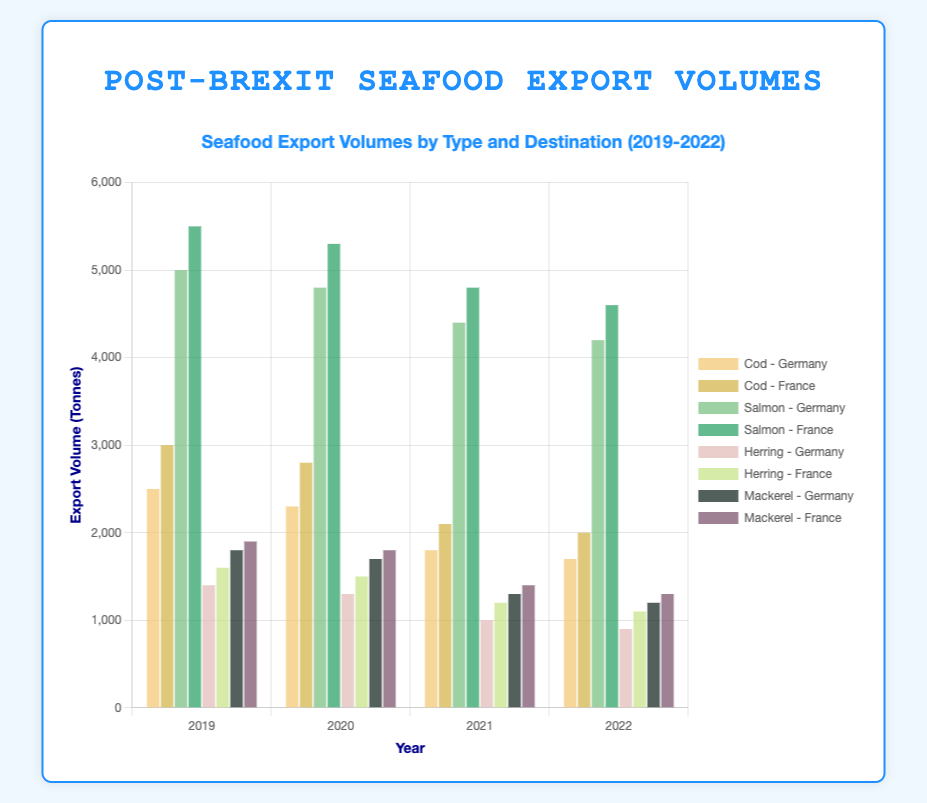What was the total export volume of Cod to Germany and France in 2019? Add the 2019 export volumes of Cod to Germany (2500 tonnes) and France (3000 tonnes). Total = 2500 + 3000 = 5500 tonnes
Answer: 5500 tonnes How did the export volume of Herring to Germany trend from 2019 to 2022? Observe the bars representing Herring exports to Germany for each year. They show a decreasing trend: 1400 tonnes in 2019, 1300 tonnes in 2020, 1000 tonnes in 2021, and 900 tonnes in 2022.
Answer: Decreasing Which seafood type had the highest export volume to France in 2022? Look for the tallest bar among the 2022 exports to France. The Salmon export volume to France in 2022 had the highest at 4600 tonnes.
Answer: Salmon What is the difference in export volume of Mackerel to Germany between 2019 and 2022? Subtract the 2022 export volume of Mackerel to Germany (1200 tonnes) from the 2019 export volume (1800 tonnes). Difference = 1800 - 1200 = 600 tonnes
Answer: 600 tonnes By how much did the export volume of Salmon to Germany decrease from 2019 to 2020? Subtract the 2020 export volume of Salmon to Germany (4800 tonnes) from the 2019 volume (5000 tonnes). Decrease = 5000 - 4800 = 200 tonnes
Answer: 200 tonnes Which year saw the largest decline in export volume of Salmon to France? Compare the decrease in volumes between consecutive years for Salmon to France: 2019-2020 (200 tonnes), 2020-2021 (500 tonnes), 2021-2022 (200 tonnes). The largest decline was in 2020-2021 with 500 tonnes.
Answer: 2020-2021 What was the combined export volume of all seafood types to France in 2021? Add the 2021 export volumes for Cod (2100 tonnes), Salmon (4800 tonnes), Herring (1200 tonnes), and Mackerel (1400 tonnes). Total = 2100 + 4800 + 1200 + 1400 = 9500 tonnes
Answer: 9500 tonnes Was the export volume of Cod to Germany higher or lower than Herring to France in 2020? Compare Cod to Germany (2300 tonnes) with Herring to France (1500 tonnes). Cod to Germany was higher.
Answer: Higher Which seafood type had the smallest difference in export volumes between Germany and France in 2022? Calculate the difference in 2022 export volumes between Germany and France for each type: Cod (300 tonnes), Salmon (400 tonnes), Herring (200 tonnes), Mackerel (100 tonnes). Mackerel had the smallest difference of 100 tonnes.
Answer: Mackerel Did the export volume of any seafood type to Germany increase from 2019 to 2022? Observe all seafood types' export volumes to Germany from 2019 to 2022. All show decreases, so none increased.
Answer: No 